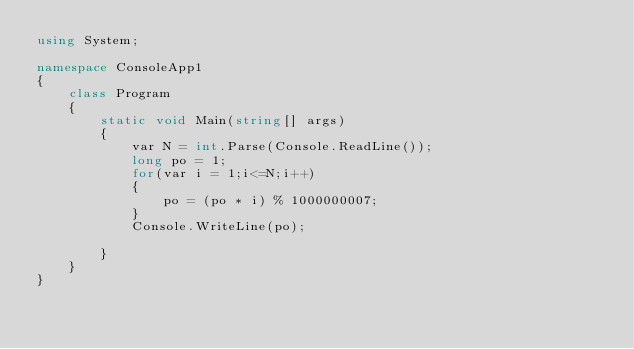<code> <loc_0><loc_0><loc_500><loc_500><_C#_>using System;

namespace ConsoleApp1
{
    class Program
    {
        static void Main(string[] args)
        {
            var N = int.Parse(Console.ReadLine());
            long po = 1;
            for(var i = 1;i<=N;i++)
            {
                po = (po * i) % 1000000007;
            }
            Console.WriteLine(po);

        }
    }
}
</code> 